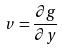Convert formula to latex. <formula><loc_0><loc_0><loc_500><loc_500>v = \frac { \partial g } { \partial y }</formula> 